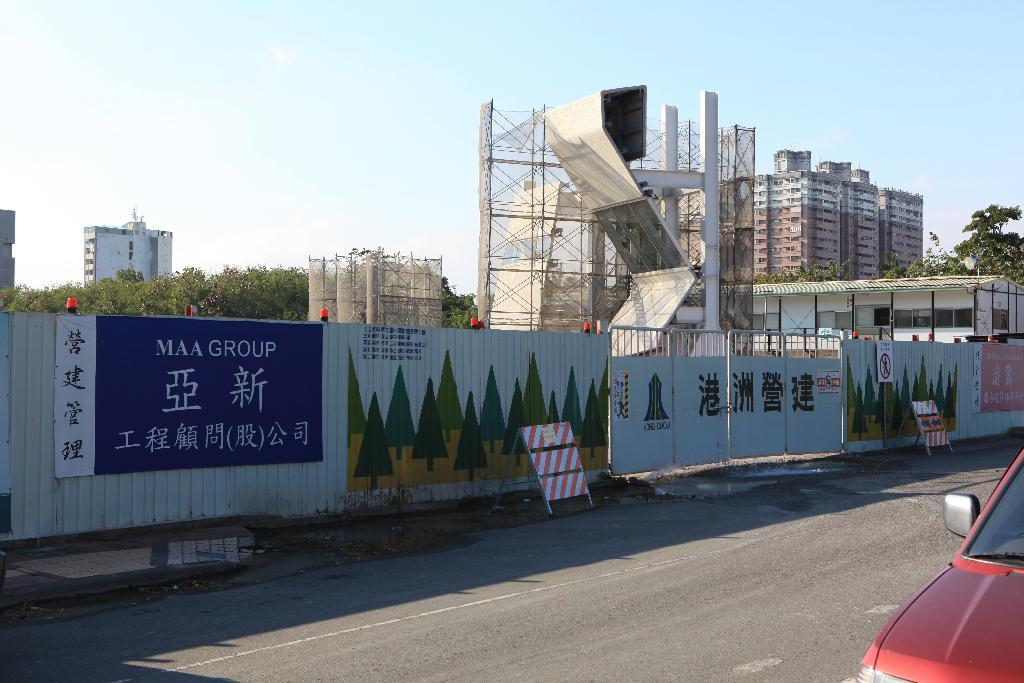What is on the road in the image? There is a vehicle on the road in the image. What objects can be seen in the foreground of the image? There are boards and a gate in the image. What structures are visible in the background of the image? There is a wall, trees, buildings, and the sky visible in the background of the image. Which actor is standing next to the gate in the image? There are no actors present in the image; it features a vehicle on the road, boards, a gate, a wall, trees, buildings, and the sky. What is the chin of the dad doing in the image? There is no dad or chin present in the image. 